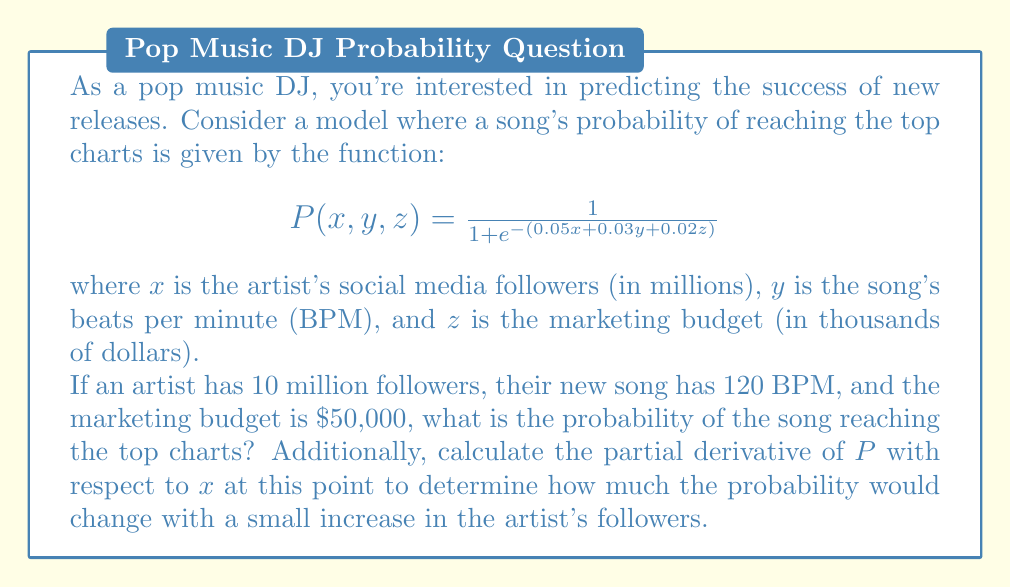Provide a solution to this math problem. To solve this problem, we'll follow these steps:

1) First, let's calculate the probability $P(x, y, z)$ at the given point:
   $x = 10$ (million followers)
   $y = 120$ (BPM)
   $z = 50$ (thousand dollars)

   $$P(10, 120, 50) = \frac{1}{1 + e^{-(0.05(10) + 0.03(120) + 0.02(50))}}$$

2) Let's simplify the exponent:
   $$0.05(10) + 0.03(120) + 0.02(50) = 0.5 + 3.6 + 1 = 5.1$$

3) Now we can calculate:
   $$P(10, 120, 50) = \frac{1}{1 + e^{-5.1}} \approx 0.9939$$

4) To find the partial derivative with respect to $x$, we use the chain rule:

   $$\frac{\partial P}{\partial x} = P(1-P) \cdot 0.05$$

5) At the point (10, 120, 50), we found that $P \approx 0.9939$. Let's substitute this:

   $$\frac{\partial P}{\partial x} \approx 0.9939(1-0.9939) \cdot 0.05 \approx 0.000152$$

This means that for a small increase in the number of followers (in millions), the probability would increase by approximately 0.000152.
Answer: The probability of the song reaching the top charts is approximately 0.9939 or 99.39%.
The partial derivative $\frac{\partial P}{\partial x}$ at the point (10, 120, 50) is approximately 0.000152. 